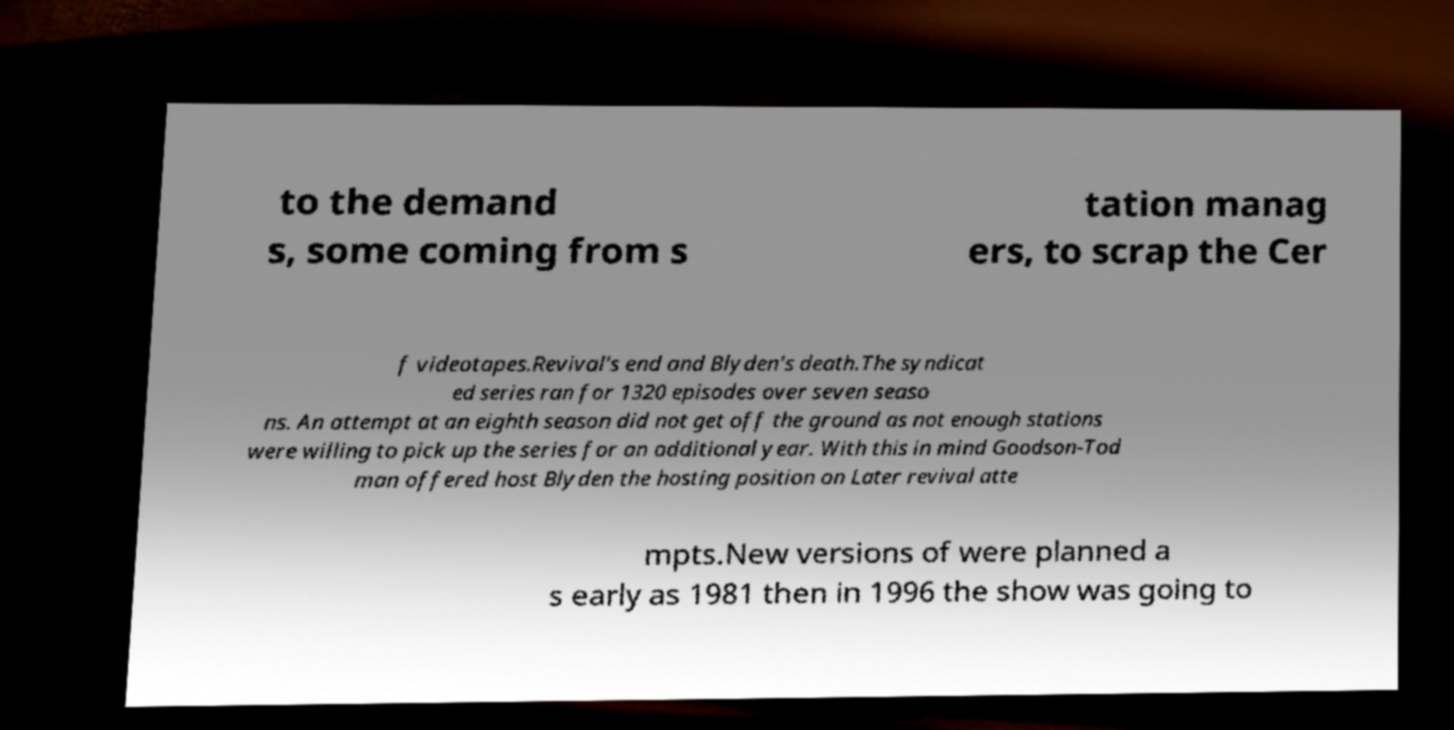Can you accurately transcribe the text from the provided image for me? to the demand s, some coming from s tation manag ers, to scrap the Cer f videotapes.Revival's end and Blyden's death.The syndicat ed series ran for 1320 episodes over seven seaso ns. An attempt at an eighth season did not get off the ground as not enough stations were willing to pick up the series for an additional year. With this in mind Goodson-Tod man offered host Blyden the hosting position on Later revival atte mpts.New versions of were planned a s early as 1981 then in 1996 the show was going to 